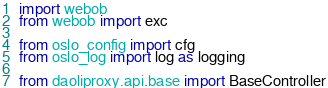<code> <loc_0><loc_0><loc_500><loc_500><_Python_>import webob
from webob import exc

from oslo_config import cfg
from oslo_log import log as logging

from daoliproxy.api.base import BaseController</code> 